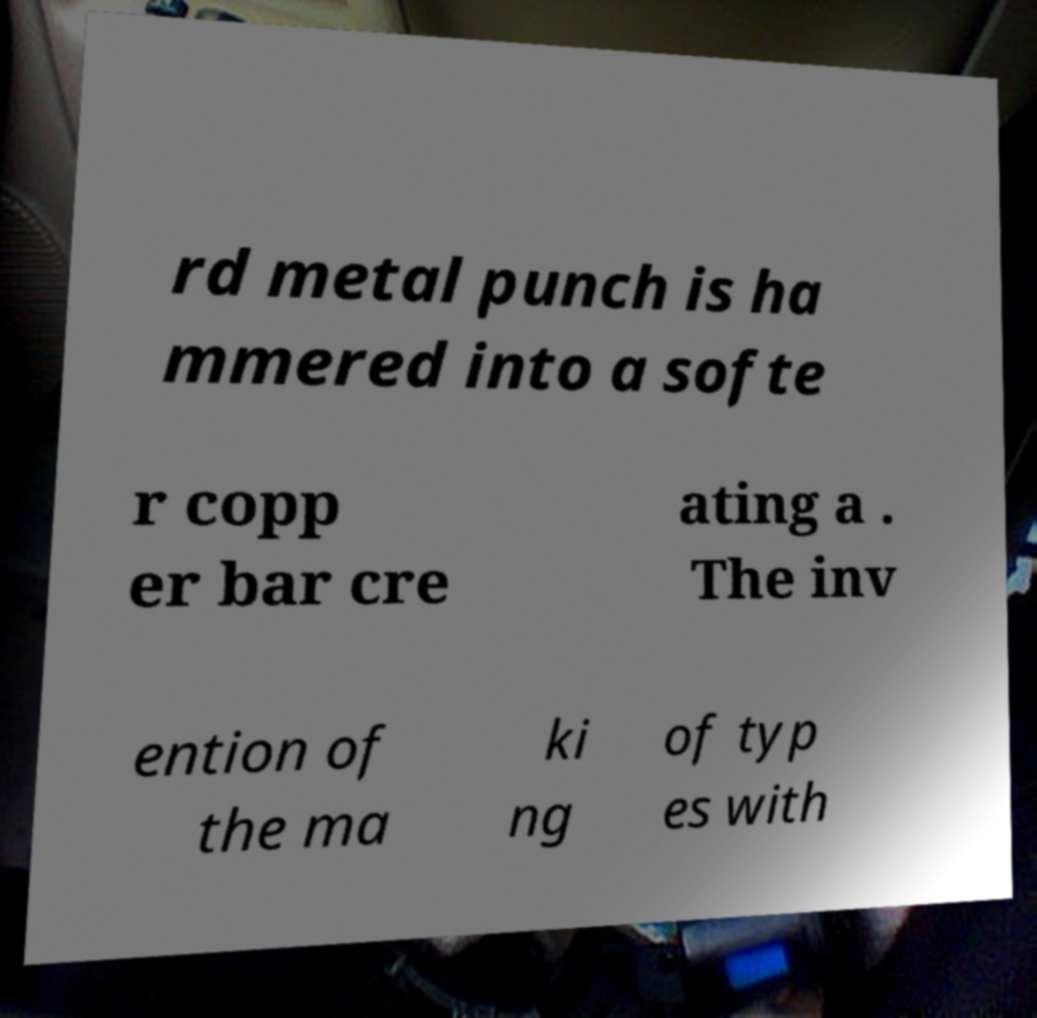Could you assist in decoding the text presented in this image and type it out clearly? rd metal punch is ha mmered into a softe r copp er bar cre ating a . The inv ention of the ma ki ng of typ es with 